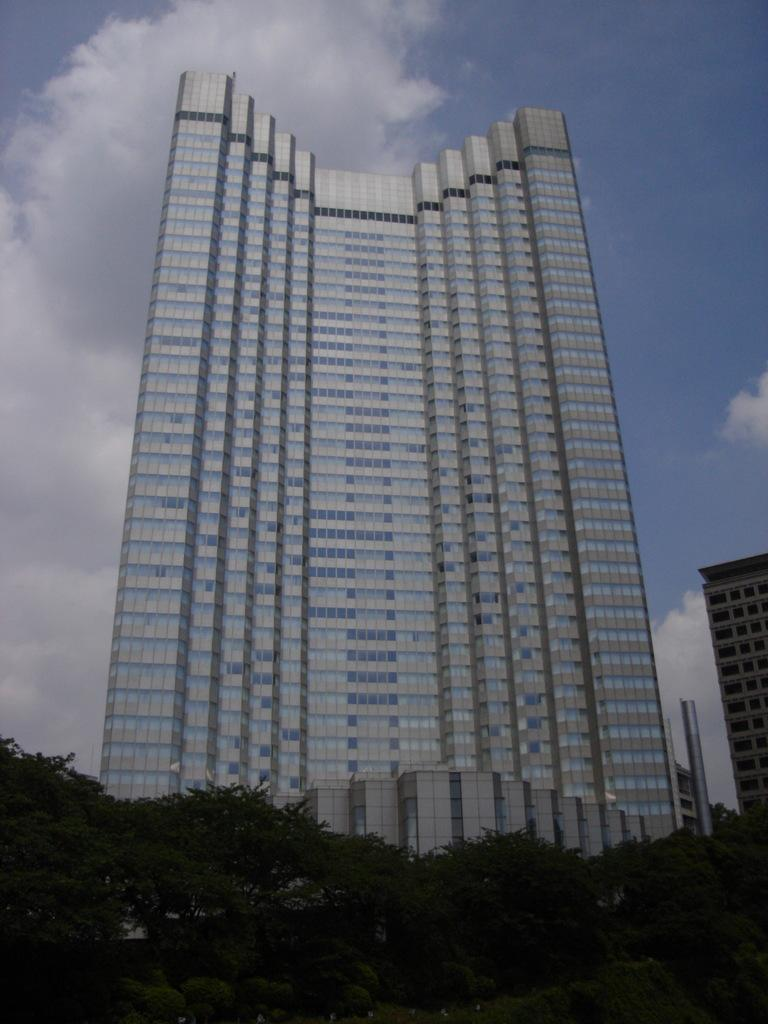What type of vegetation can be seen in the image? There are trees in the image. What is the color of the trees? The trees are green. What is located in the background of the image? There is a building in the background of the image. What is the color of the building? The building is white. What is visible above the trees and the building? The sky is visible in the image. What colors can be seen in the sky? The sky is blue and white. Can you see any airplanes taking off or landing at the nearby airport in the image? There is no airport or airplanes visible in the image; it only features trees, a white building, and a blue and white sky. 